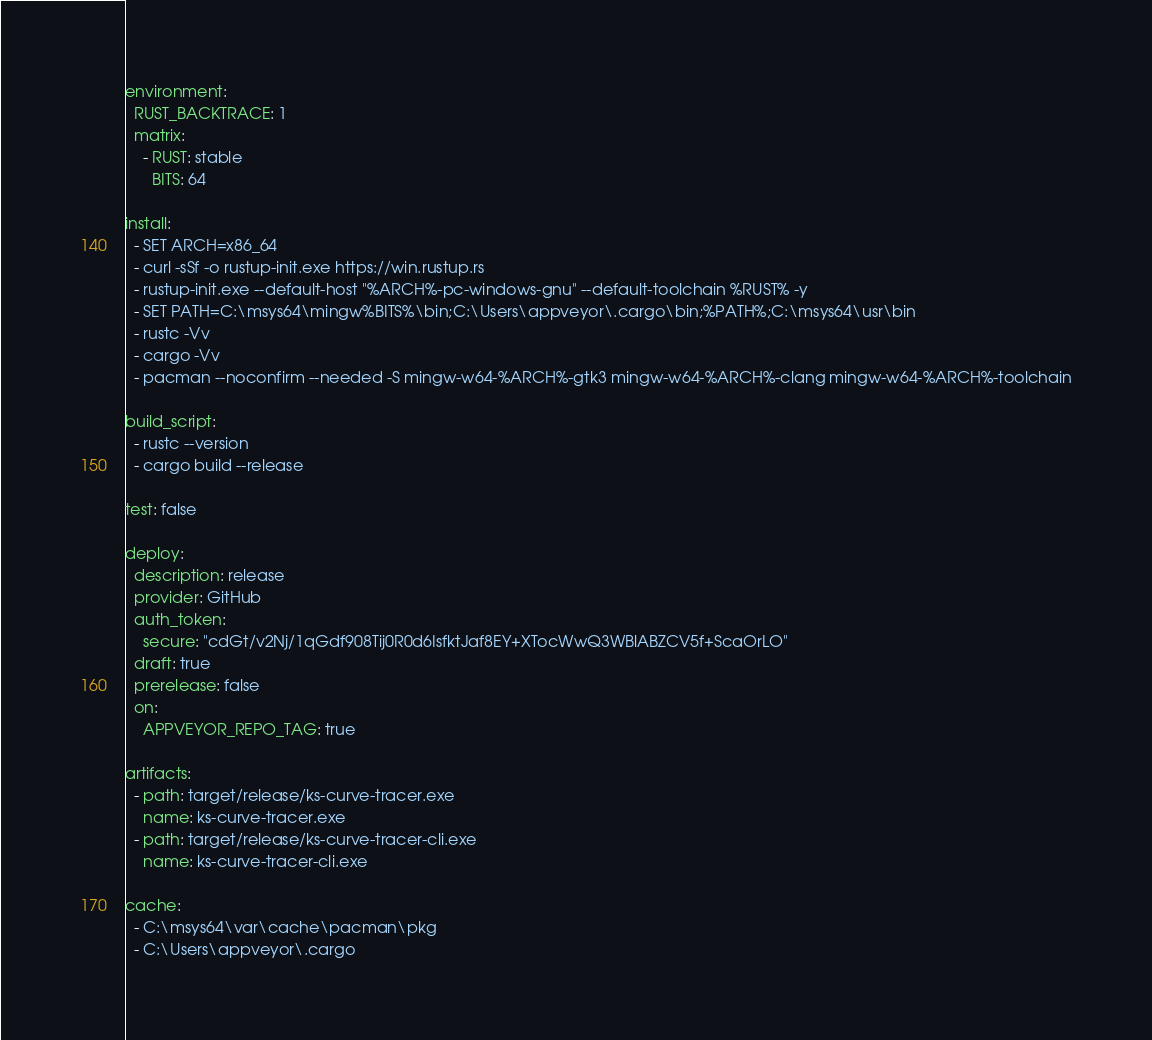Convert code to text. <code><loc_0><loc_0><loc_500><loc_500><_YAML_>environment:
  RUST_BACKTRACE: 1
  matrix:
    - RUST: stable
      BITS: 64

install:
  - SET ARCH=x86_64
  - curl -sSf -o rustup-init.exe https://win.rustup.rs
  - rustup-init.exe --default-host "%ARCH%-pc-windows-gnu" --default-toolchain %RUST% -y
  - SET PATH=C:\msys64\mingw%BITS%\bin;C:\Users\appveyor\.cargo\bin;%PATH%;C:\msys64\usr\bin
  - rustc -Vv
  - cargo -Vv
  - pacman --noconfirm --needed -S mingw-w64-%ARCH%-gtk3 mingw-w64-%ARCH%-clang mingw-w64-%ARCH%-toolchain

build_script:
  - rustc --version
  - cargo build --release

test: false

deploy:
  description: release
  provider: GitHub
  auth_token:
    secure: "cdGt/v2Nj/1qGdf908Tij0R0d6IsfktJaf8EY+XTocWwQ3WBlABZCV5f+ScaOrLO"
  draft: true
  prerelease: false
  on:
    APPVEYOR_REPO_TAG: true

artifacts:
  - path: target/release/ks-curve-tracer.exe
    name: ks-curve-tracer.exe
  - path: target/release/ks-curve-tracer-cli.exe
    name: ks-curve-tracer-cli.exe

cache:
  - C:\msys64\var\cache\pacman\pkg
  - C:\Users\appveyor\.cargo
</code> 